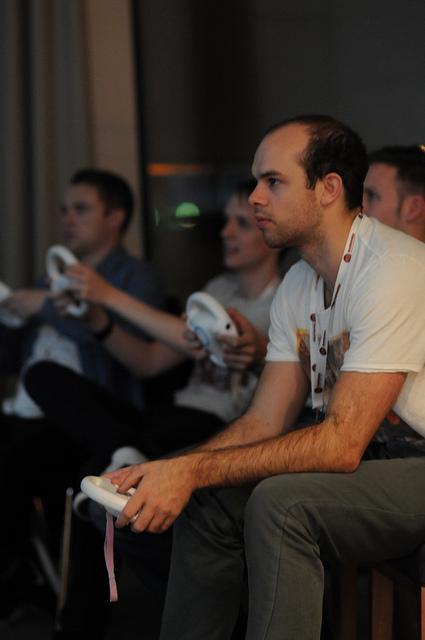How many people are holding controllers?
Give a very brief answer. 4. How many chairs are in the picture?
Give a very brief answer. 1. How many people are in the photo?
Give a very brief answer. 4. How many skateboards are pictured off the ground?
Give a very brief answer. 0. 